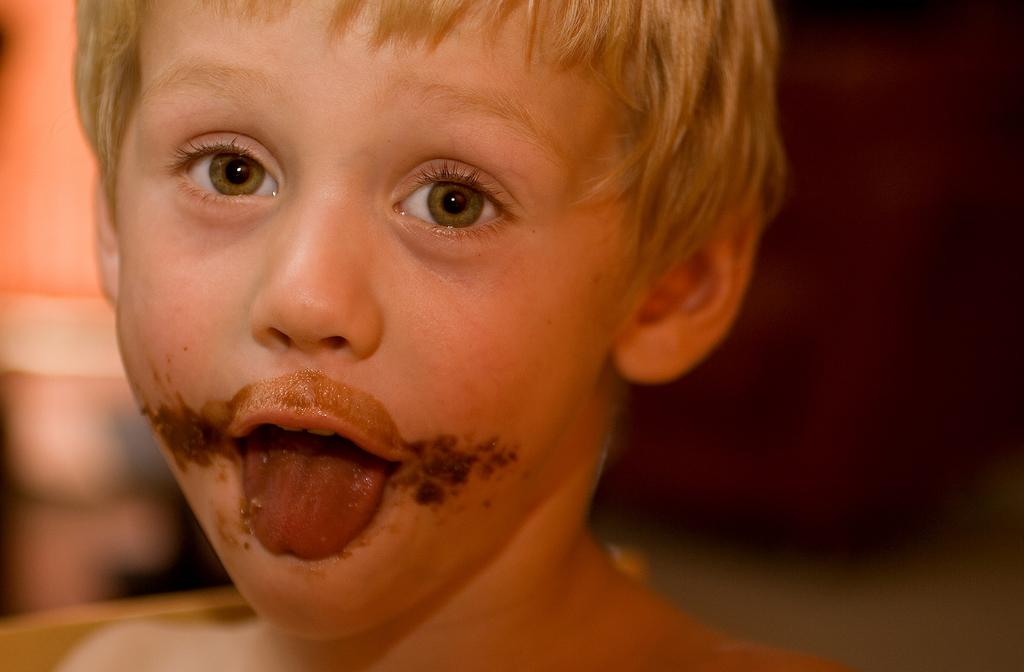What is the appearance of the boy in the image? There is a blond-haired boy in the image. What is the boy doing in the image? The boy is opening his mouth. What can be seen around the boy's mouth? There are objects on the sides of his mouth. Can you describe the background of the image? The background of the image is blurry. How many snails can be seen crawling on the boy's face in the image? There are no snails present in the image. What event is taking place in the image? The facts provided do not mention any specific event occurring in the image. 